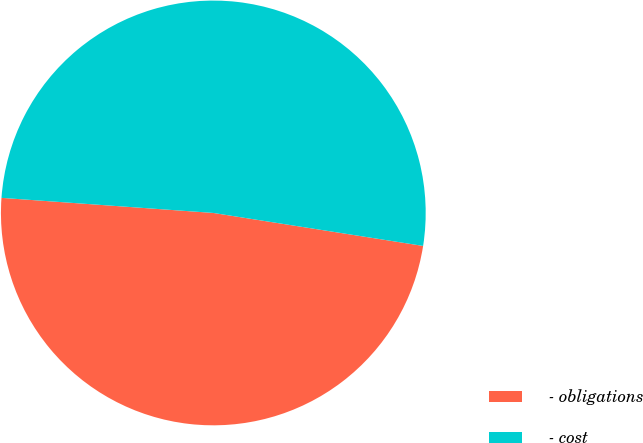Convert chart. <chart><loc_0><loc_0><loc_500><loc_500><pie_chart><fcel>- obligations<fcel>- cost<nl><fcel>48.65%<fcel>51.35%<nl></chart> 